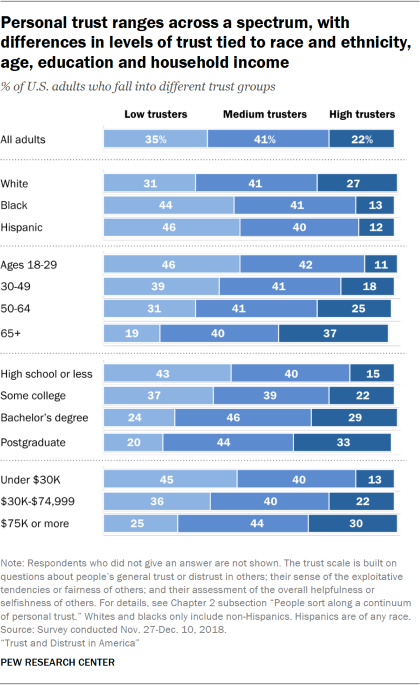Identify some key points in this picture. In how many categories are there more high trusters than low trusters? There are 4 such categories. According to a recent study, the percentage of adults who are high trusters is approximately 22%. 